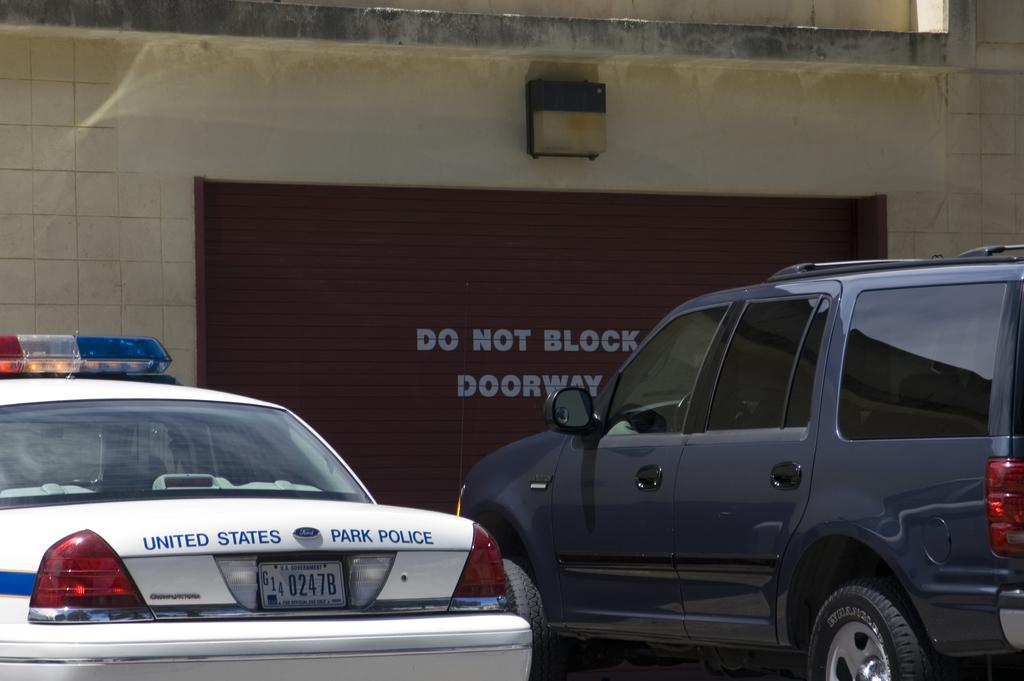How many cars are parked in the image? There are two cars parked in the image. What type of shutter is present in the image? There is a rolling shutter in the image. Where is the lamp located in the image? The lamp is attached to a wall in the image. What type of locket is hanging from the lamp in the image? There is no locket present in the image; the lamp is attached to a wall. What kind of insect can be seen crawling on the cars in the image? There are no insects visible in the image; it only shows two parked cars, a rolling shutter, and a lamp attached to a wall. 